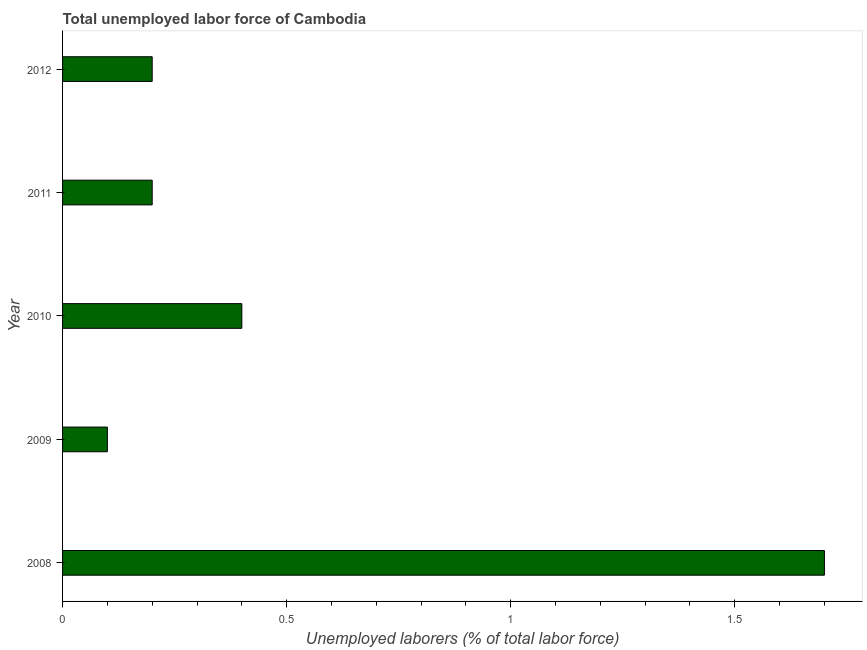Does the graph contain any zero values?
Your answer should be very brief. No. What is the title of the graph?
Make the answer very short. Total unemployed labor force of Cambodia. What is the label or title of the X-axis?
Make the answer very short. Unemployed laborers (% of total labor force). What is the total unemployed labour force in 2008?
Make the answer very short. 1.7. Across all years, what is the maximum total unemployed labour force?
Your answer should be very brief. 1.7. Across all years, what is the minimum total unemployed labour force?
Keep it short and to the point. 0.1. In which year was the total unemployed labour force maximum?
Offer a very short reply. 2008. In which year was the total unemployed labour force minimum?
Keep it short and to the point. 2009. What is the sum of the total unemployed labour force?
Make the answer very short. 2.6. What is the difference between the total unemployed labour force in 2008 and 2012?
Give a very brief answer. 1.5. What is the average total unemployed labour force per year?
Keep it short and to the point. 0.52. What is the median total unemployed labour force?
Keep it short and to the point. 0.2. In how many years, is the total unemployed labour force greater than 0.7 %?
Provide a succinct answer. 1. What is the ratio of the total unemployed labour force in 2008 to that in 2009?
Your response must be concise. 17. Is the total unemployed labour force in 2009 less than that in 2010?
Provide a succinct answer. Yes. Is the difference between the total unemployed labour force in 2010 and 2011 greater than the difference between any two years?
Offer a terse response. No. What is the difference between the highest and the second highest total unemployed labour force?
Your answer should be compact. 1.3. Is the sum of the total unemployed labour force in 2008 and 2012 greater than the maximum total unemployed labour force across all years?
Provide a short and direct response. Yes. What is the difference between the highest and the lowest total unemployed labour force?
Provide a succinct answer. 1.6. How many bars are there?
Your response must be concise. 5. What is the Unemployed laborers (% of total labor force) in 2008?
Your answer should be very brief. 1.7. What is the Unemployed laborers (% of total labor force) in 2009?
Your answer should be very brief. 0.1. What is the Unemployed laborers (% of total labor force) in 2010?
Make the answer very short. 0.4. What is the Unemployed laborers (% of total labor force) of 2011?
Your answer should be very brief. 0.2. What is the Unemployed laborers (% of total labor force) of 2012?
Your response must be concise. 0.2. What is the difference between the Unemployed laborers (% of total labor force) in 2008 and 2009?
Provide a short and direct response. 1.6. What is the difference between the Unemployed laborers (% of total labor force) in 2008 and 2010?
Provide a succinct answer. 1.3. What is the difference between the Unemployed laborers (% of total labor force) in 2008 and 2011?
Keep it short and to the point. 1.5. What is the difference between the Unemployed laborers (% of total labor force) in 2009 and 2012?
Your answer should be compact. -0.1. What is the difference between the Unemployed laborers (% of total labor force) in 2011 and 2012?
Offer a terse response. 0. What is the ratio of the Unemployed laborers (% of total labor force) in 2008 to that in 2009?
Ensure brevity in your answer.  17. What is the ratio of the Unemployed laborers (% of total labor force) in 2008 to that in 2010?
Keep it short and to the point. 4.25. What is the ratio of the Unemployed laborers (% of total labor force) in 2008 to that in 2011?
Offer a terse response. 8.5. What is the ratio of the Unemployed laborers (% of total labor force) in 2009 to that in 2010?
Your answer should be compact. 0.25. What is the ratio of the Unemployed laborers (% of total labor force) in 2010 to that in 2011?
Your response must be concise. 2. What is the ratio of the Unemployed laborers (% of total labor force) in 2011 to that in 2012?
Your answer should be compact. 1. 